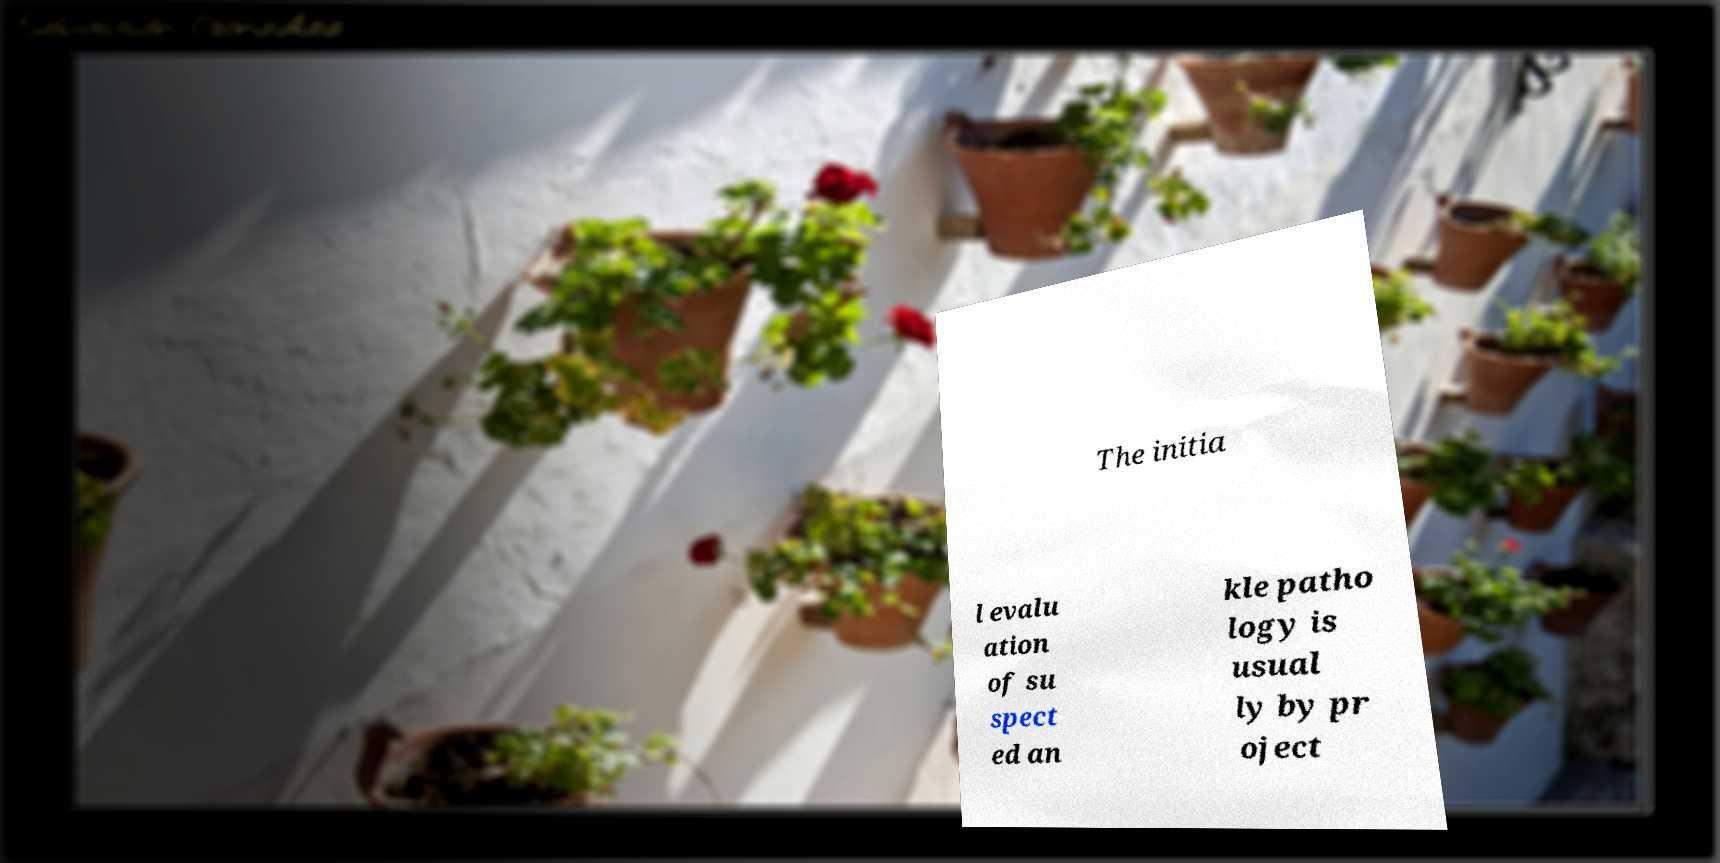I need the written content from this picture converted into text. Can you do that? The initia l evalu ation of su spect ed an kle patho logy is usual ly by pr oject 